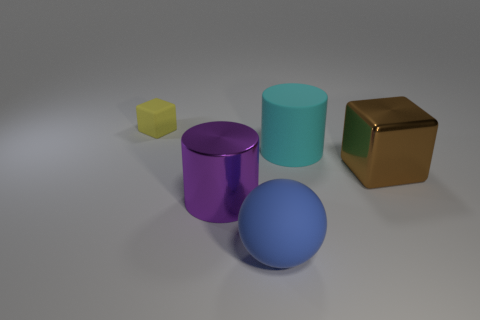How many tiny yellow cubes are left of the metal thing that is in front of the brown object?
Ensure brevity in your answer.  1. How many cylinders are small yellow matte objects or blue objects?
Keep it short and to the point. 0. Are there any yellow objects?
Offer a very short reply. Yes. There is a yellow rubber thing that is the same shape as the brown metallic thing; what size is it?
Your answer should be very brief. Small. There is a big metal thing that is in front of the block on the right side of the tiny matte thing; what shape is it?
Your answer should be compact. Cylinder. What number of purple objects are large things or shiny cylinders?
Offer a very short reply. 1. The big block has what color?
Provide a short and direct response. Brown. Do the purple metal cylinder and the yellow object have the same size?
Make the answer very short. No. Is there anything else that has the same shape as the big blue rubber thing?
Ensure brevity in your answer.  No. Is the blue thing made of the same material as the cylinder to the left of the large matte cylinder?
Provide a short and direct response. No. 